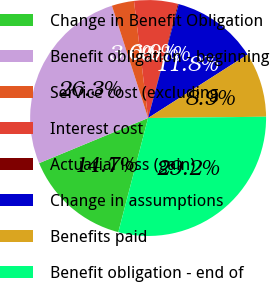Convert chart. <chart><loc_0><loc_0><loc_500><loc_500><pie_chart><fcel>Change in Benefit Obligation<fcel>Benefit obligation - beginning<fcel>Service cost (excluding<fcel>Interest cost<fcel>Actuarial loss (gain)<fcel>Change in assumptions<fcel>Benefits paid<fcel>Benefit obligation - end of<nl><fcel>14.69%<fcel>26.29%<fcel>3.05%<fcel>5.96%<fcel>0.13%<fcel>11.78%<fcel>8.87%<fcel>29.24%<nl></chart> 